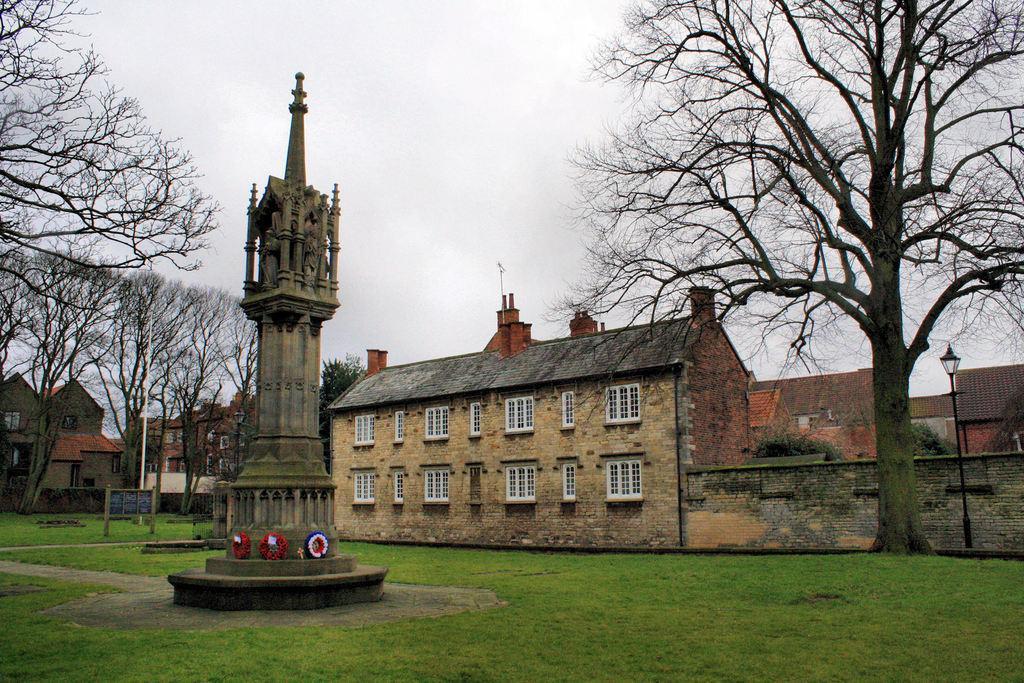Could you give a brief overview of what you see in this image? This image is taken outdoors. At the bottom of the image there is a ground with grass on it. At the top of the image there is a sky with clouds. On the left and right sides of the image there are a few trees and street lights. In the background there are a few houses with walls, windows, roofs and doors. In the middle of the image there is a tower with sculptures on it. 